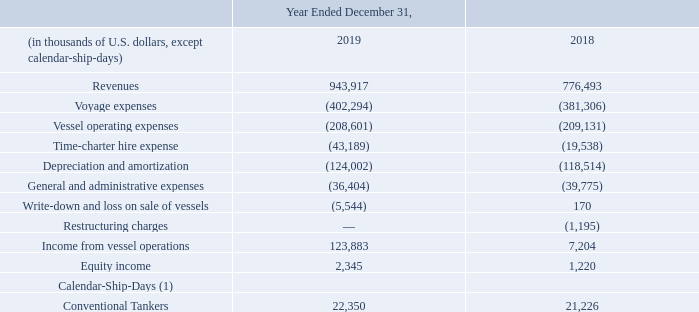Operating Results – Teekay Tankers
The following table compares Teekay Tankers’ operating results, equity income and number of calendar-ship-days for its vessels for 2019 and 2018.
(1) Calendar-ship-days presented relate to owned and in-chartered consolidated vessels.
Teekay Tankers' income from vessel operations increased to $123.9 million in 2019 compared to $7.2 million in 2018, primarily as a result of: • an increase of $129.3 million due to higher overall average realized spot tanker rates earned by Teekay Tankers' Suezmax, Aframax and LR2 product tankers; • an increase of $3.5 million due to improved net results from Teekay Tankers' full service lightering (or FSL) activities from more voyage days and higher realized spot rates earned;
• an increase of $3.4 million resulting from lower general and administrative expenses primarily due to non-recurring project expenses incurred in 2018; • a net increase of $2.3 million primarily due to the delivery of three Aframax and two LR2 chartered-in tankers in late 2018 and throughout 2019, partially offset by the redeliveries of various in-chartered tankers to their owners in the second and third quarters of 2018; and • an increase of $1.2 million as a result of restructuring charge incurred in the prior year;
partially offset by
• a decrease of $10.2 million due to a higher number of off-hire days in 2019 resulting from dry dockings and higher off-hire bunker expenses compared to the prior year; • a decrease of $6.9 million due to lower revenues and loss on the sale of one Suezmax tanker in 2019 and the write-down of two Suezmax tankers that were classified as held for sale at December 31, 2019; and • a decrease of $6.4 million due to the amortization of first dry dockings for various former Tanker Investments Ltd. (or TIL) vessels subsequent to Teekay Tankers' acquisition of TIL in late 2017.
Equity income increased to $2.3 million in 2019 from $1.2 million in 2018 primarily due to higher earnings recognized in 2019 from the High-Q Investment Ltd. joint venture as a result of higher spot rates earned in 2019.
What led to increase in Equity income in 2019? Primarily due to higher earnings recognized in 2019 from the high-q investment ltd. joint venture as a result of higher spot rates earned in 2019. What is the increase/ (decrease) in Revenues from, 2019 to 2018?
Answer scale should be: thousand. 943,917-776,493
Answer: 167424. What is the increase/ (decrease) in Voyage expenses from, 2019 to 2018?
Answer scale should be: thousand. 402,294-381,306
Answer: 20988. In which year was revenue less than 800,000 thousands? Locate and analyze revenue in row 3
answer: 2018. What was the increase in Teekay Tankers' income from vessel operations in 2019? $123.9 million. What was the increase due to lower general and administrative expenses? $3.4 million. 